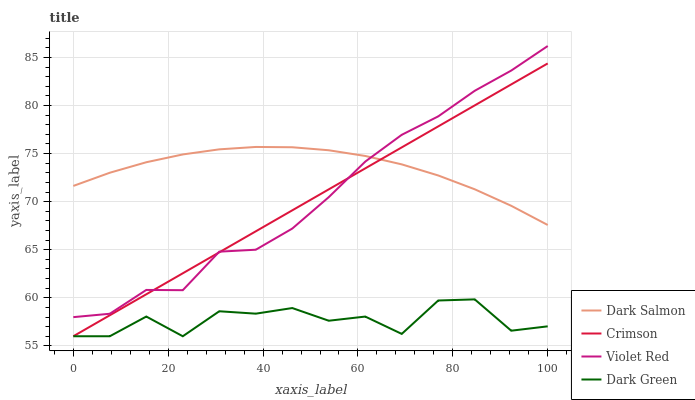Does Violet Red have the minimum area under the curve?
Answer yes or no. No. Does Violet Red have the maximum area under the curve?
Answer yes or no. No. Is Violet Red the smoothest?
Answer yes or no. No. Is Violet Red the roughest?
Answer yes or no. No. Does Violet Red have the lowest value?
Answer yes or no. No. Does Dark Salmon have the highest value?
Answer yes or no. No. Is Dark Green less than Dark Salmon?
Answer yes or no. Yes. Is Violet Red greater than Dark Green?
Answer yes or no. Yes. Does Dark Green intersect Dark Salmon?
Answer yes or no. No. 